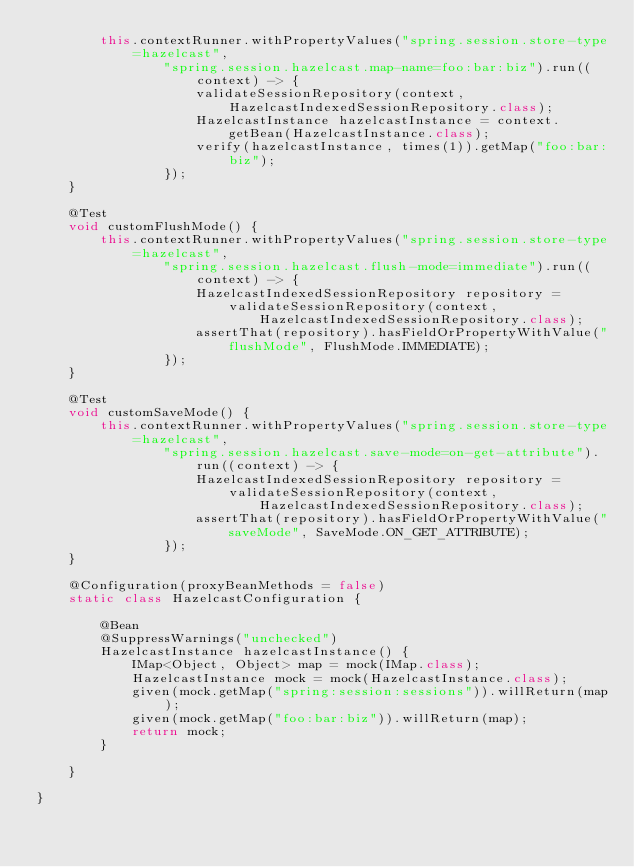Convert code to text. <code><loc_0><loc_0><loc_500><loc_500><_Java_>		this.contextRunner.withPropertyValues("spring.session.store-type=hazelcast",
				"spring.session.hazelcast.map-name=foo:bar:biz").run((context) -> {
					validateSessionRepository(context, HazelcastIndexedSessionRepository.class);
					HazelcastInstance hazelcastInstance = context.getBean(HazelcastInstance.class);
					verify(hazelcastInstance, times(1)).getMap("foo:bar:biz");
				});
	}

	@Test
	void customFlushMode() {
		this.contextRunner.withPropertyValues("spring.session.store-type=hazelcast",
				"spring.session.hazelcast.flush-mode=immediate").run((context) -> {
					HazelcastIndexedSessionRepository repository = validateSessionRepository(context,
							HazelcastIndexedSessionRepository.class);
					assertThat(repository).hasFieldOrPropertyWithValue("flushMode", FlushMode.IMMEDIATE);
				});
	}

	@Test
	void customSaveMode() {
		this.contextRunner.withPropertyValues("spring.session.store-type=hazelcast",
				"spring.session.hazelcast.save-mode=on-get-attribute").run((context) -> {
					HazelcastIndexedSessionRepository repository = validateSessionRepository(context,
							HazelcastIndexedSessionRepository.class);
					assertThat(repository).hasFieldOrPropertyWithValue("saveMode", SaveMode.ON_GET_ATTRIBUTE);
				});
	}

	@Configuration(proxyBeanMethods = false)
	static class HazelcastConfiguration {

		@Bean
		@SuppressWarnings("unchecked")
		HazelcastInstance hazelcastInstance() {
			IMap<Object, Object> map = mock(IMap.class);
			HazelcastInstance mock = mock(HazelcastInstance.class);
			given(mock.getMap("spring:session:sessions")).willReturn(map);
			given(mock.getMap("foo:bar:biz")).willReturn(map);
			return mock;
		}

	}

}
</code> 